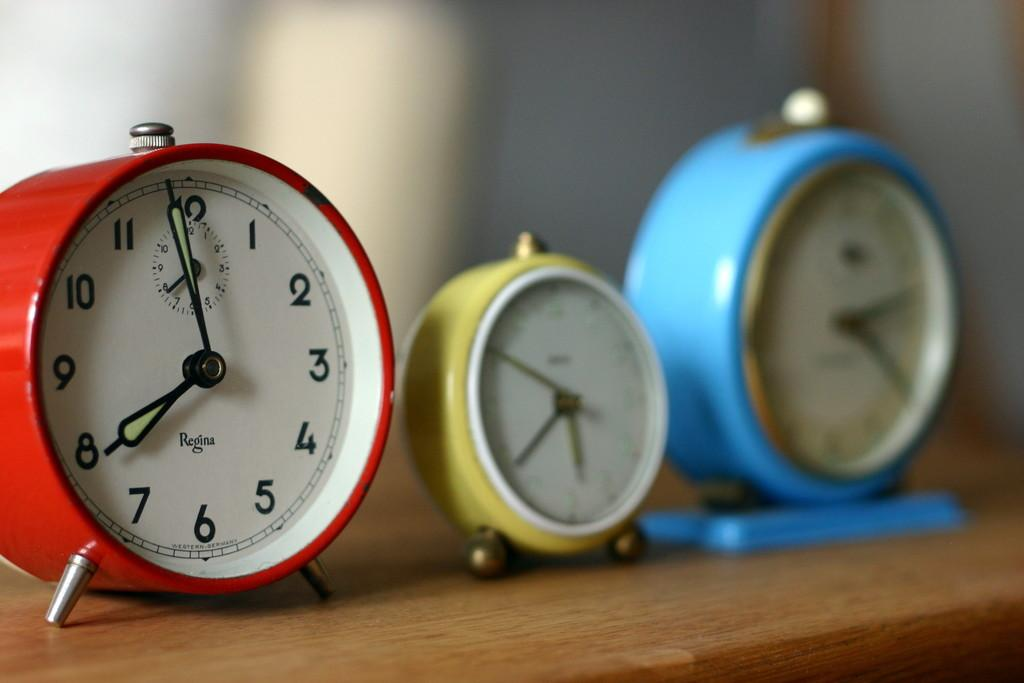<image>
Offer a succinct explanation of the picture presented. 3 clocks next to each other with one of them showing 8 o'clock on it 